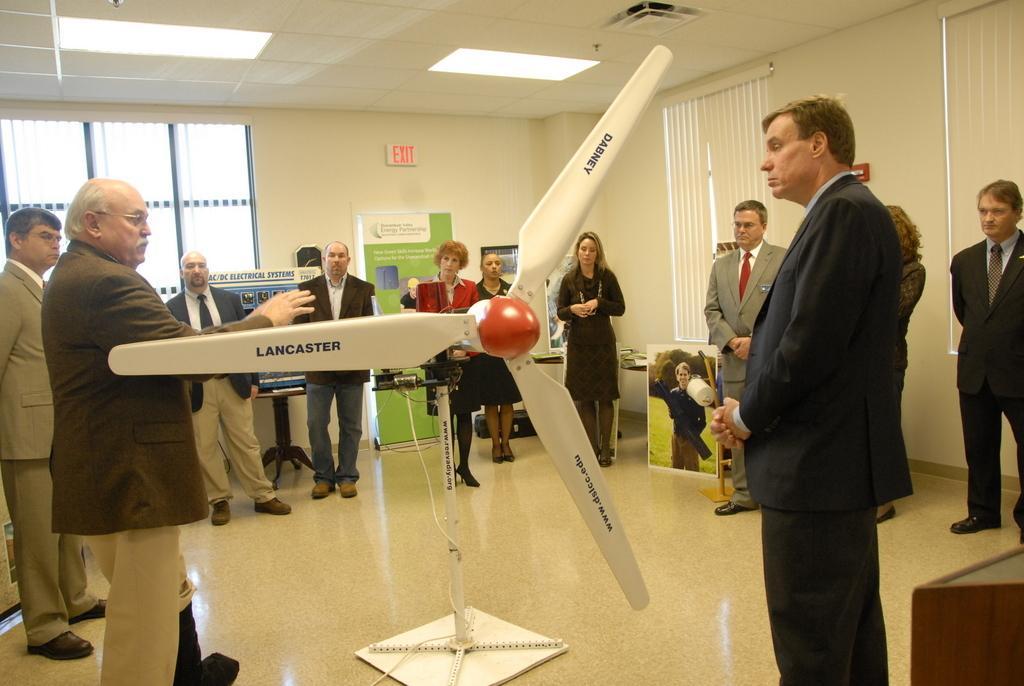Can you describe this image briefly? In this image there are people standing on a floor, in the middle there is a fan, in the background there are walls for that walls there are windows and curtains, at the top there is a ceiling and lights. 